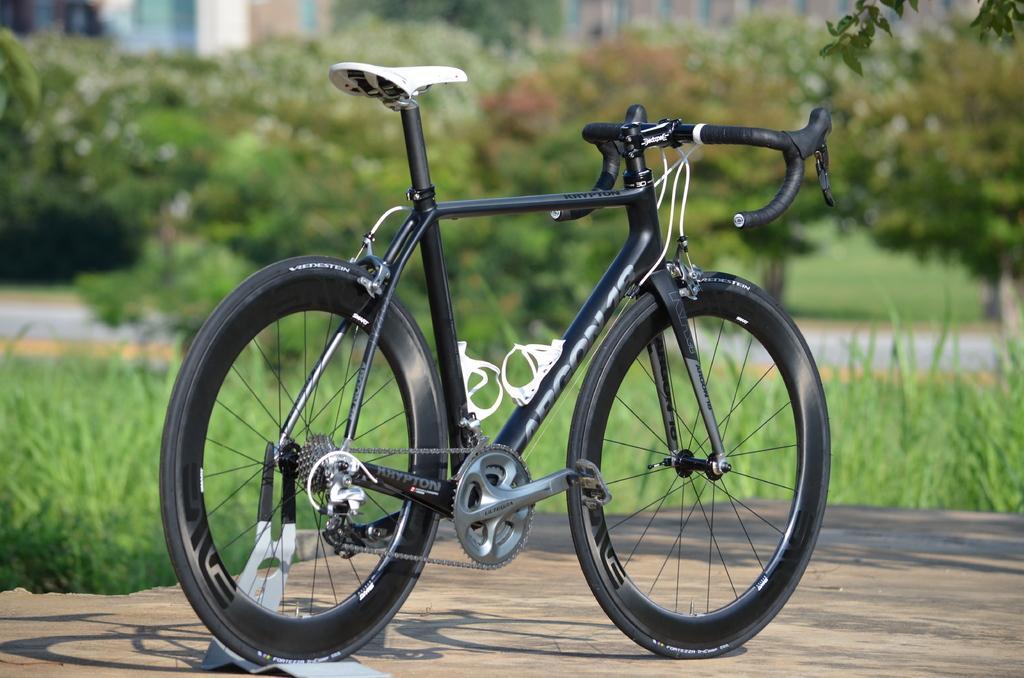Describe this image in one or two sentences. In the foreground of this image, there is a bicycle on the stone surface. In the background, there is greenery and a road and the remaining objects are not clear. 